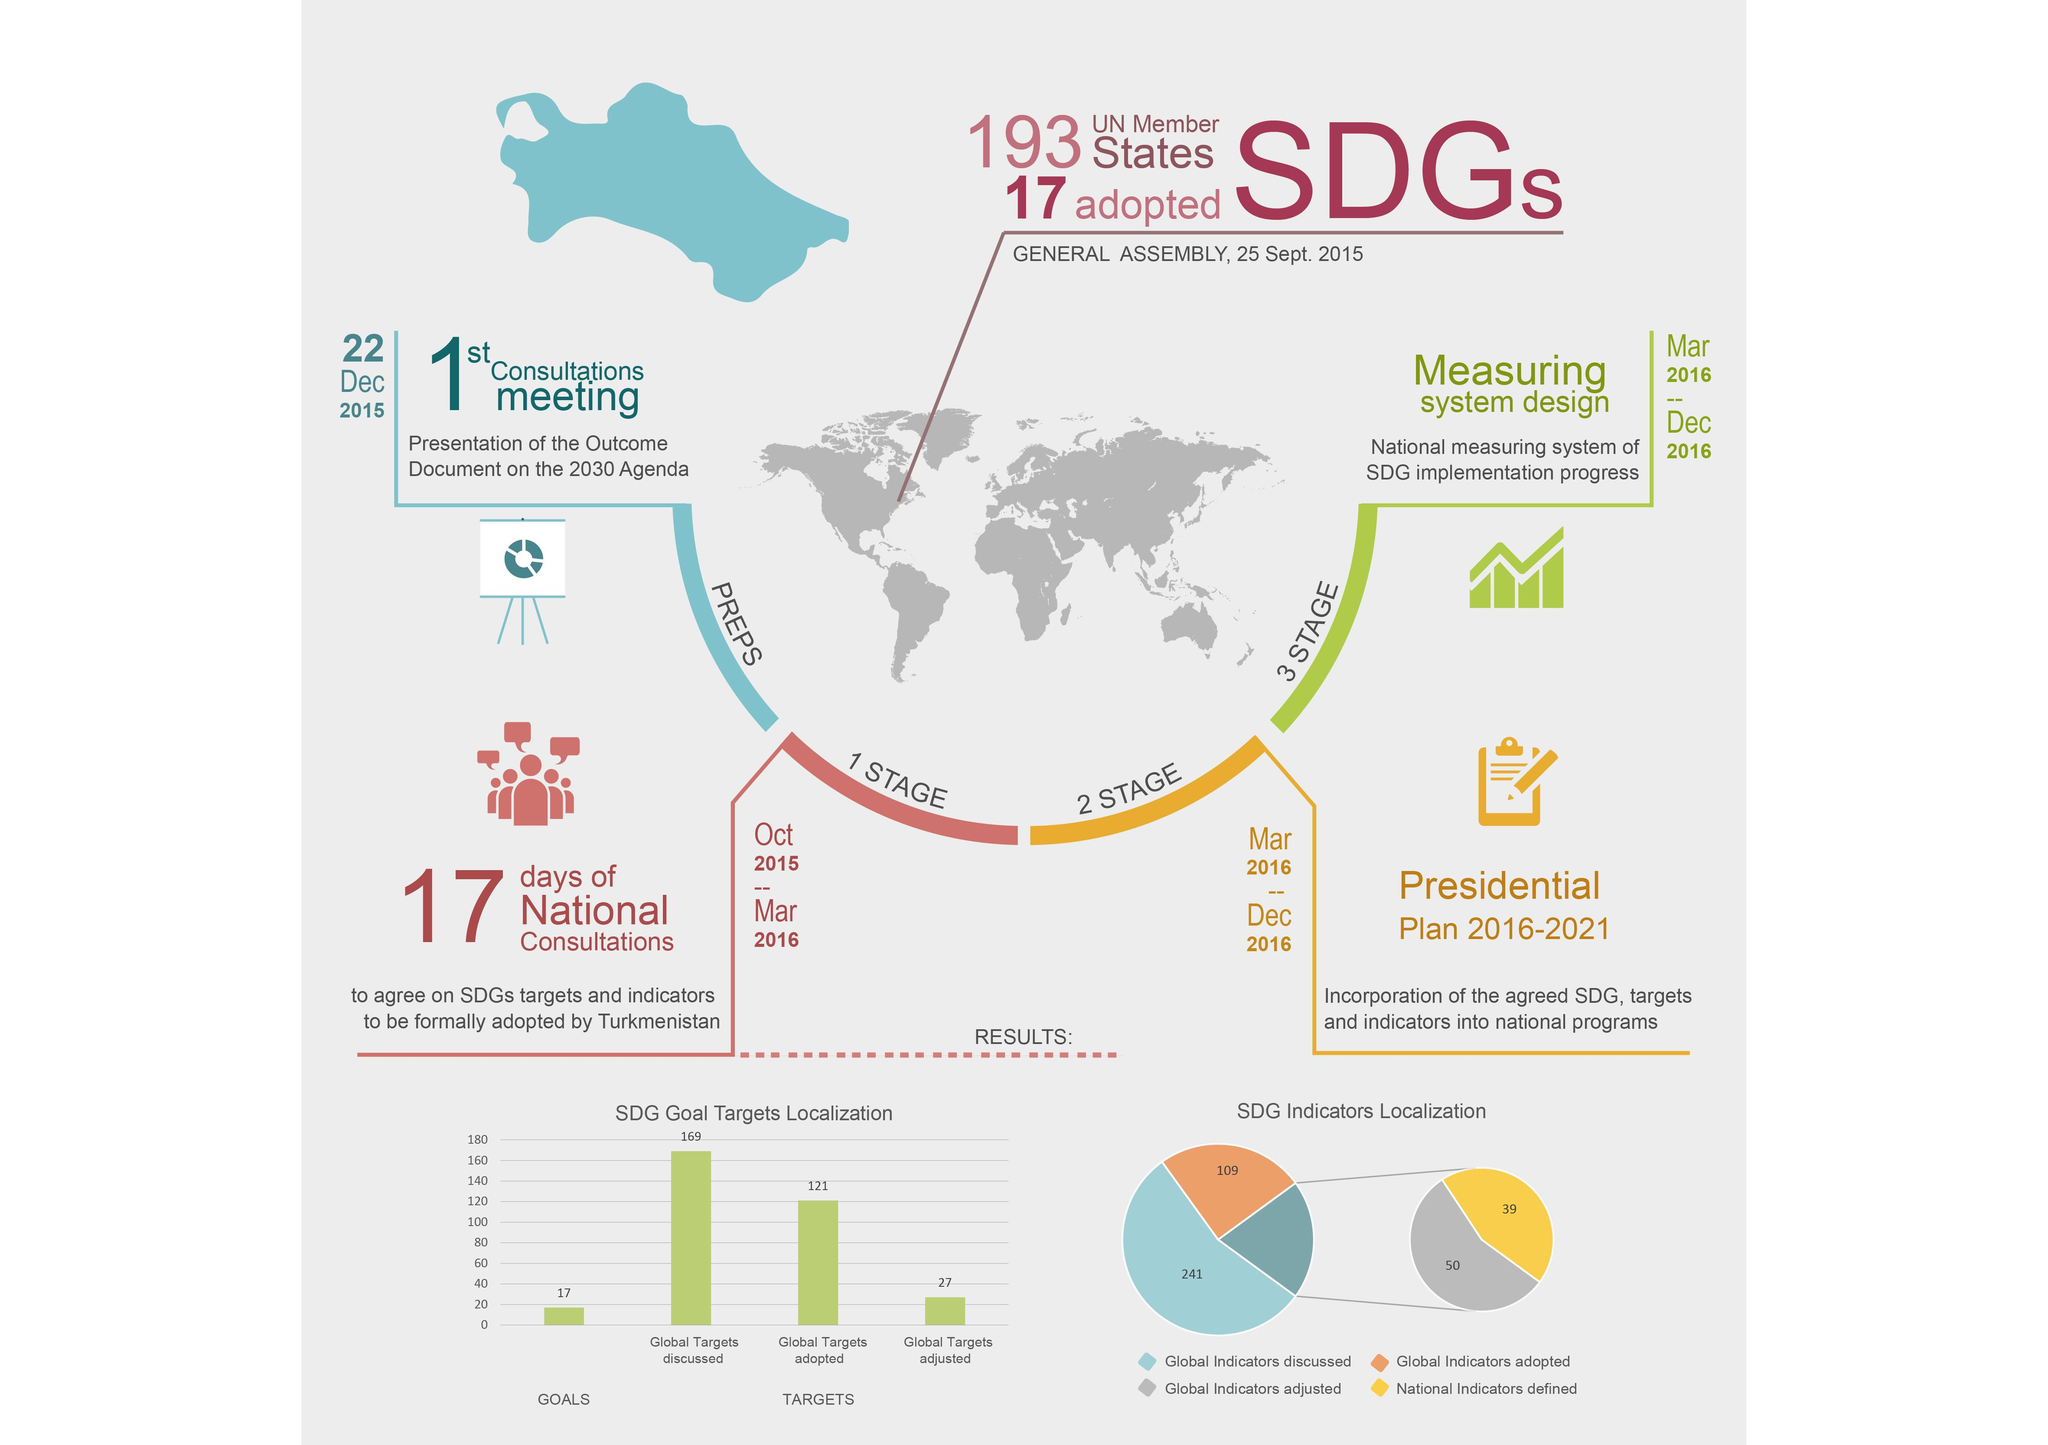List a handful of essential elements in this visual. The global targets discussed and adopted during the meeting are 48. The color that represents the preparation stage is blue. 